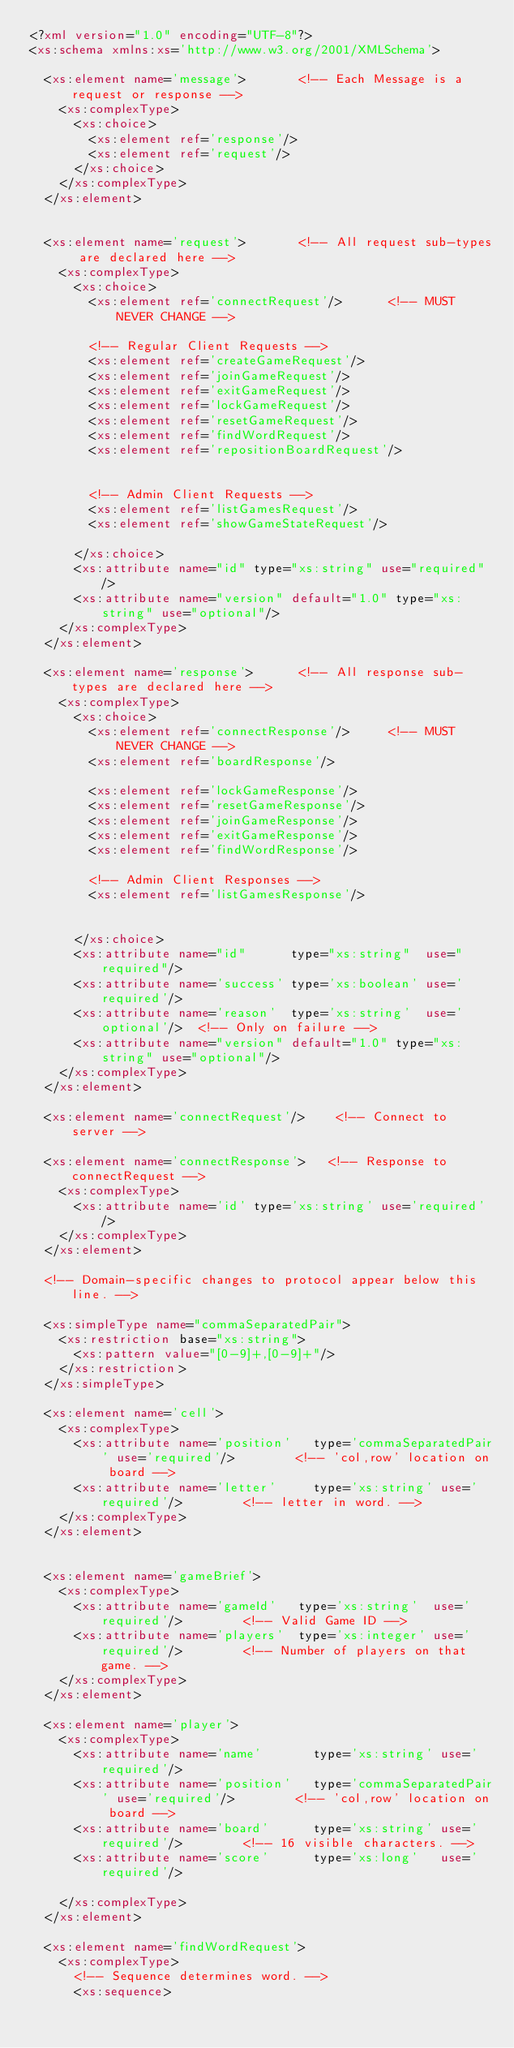<code> <loc_0><loc_0><loc_500><loc_500><_XML_><?xml version="1.0" encoding="UTF-8"?>
<xs:schema xmlns:xs='http://www.w3.org/2001/XMLSchema'>

  <xs:element name='message'>       <!-- Each Message is a request or response -->
    <xs:complexType>
      <xs:choice>
        <xs:element ref='response'/>
        <xs:element ref='request'/>
      </xs:choice>
    </xs:complexType>
  </xs:element>


  <xs:element name='request'>       <!-- All request sub-types are declared here -->
    <xs:complexType>
      <xs:choice>
        <xs:element ref='connectRequest'/>      <!-- MUST NEVER CHANGE -->

        <!-- Regular Client Requests -->
        <xs:element ref='createGameRequest'/>
        <xs:element ref='joinGameRequest'/>
        <xs:element ref='exitGameRequest'/>
        <xs:element ref='lockGameRequest'/>
        <xs:element ref='resetGameRequest'/>
        <xs:element ref='findWordRequest'/>
        <xs:element ref='repositionBoardRequest'/>


        <!-- Admin Client Requests -->
        <xs:element ref='listGamesRequest'/>
        <xs:element ref='showGameStateRequest'/>

      </xs:choice>
      <xs:attribute name="id" type="xs:string" use="required"/>
      <xs:attribute name="version" default="1.0" type="xs:string" use="optional"/>
    </xs:complexType>
  </xs:element>

  <xs:element name='response'>      <!-- All response sub-types are declared here -->
    <xs:complexType>
      <xs:choice>
        <xs:element ref='connectResponse'/>     <!-- MUST NEVER CHANGE -->
        <xs:element ref='boardResponse'/>

        <xs:element ref='lockGameResponse'/>
        <xs:element ref='resetGameResponse'/>
        <xs:element ref='joinGameResponse'/>
        <xs:element ref='exitGameResponse'/>
        <xs:element ref='findWordResponse'/>

        <!-- Admin Client Responses -->
        <xs:element ref='listGamesResponse'/>


      </xs:choice>
      <xs:attribute name="id"      type="xs:string"  use="required"/>
      <xs:attribute name='success' type='xs:boolean' use='required'/>
      <xs:attribute name='reason'  type='xs:string'  use='optional'/>  <!-- Only on failure -->
      <xs:attribute name="version" default="1.0" type="xs:string" use="optional"/>
    </xs:complexType>
  </xs:element>

  <xs:element name='connectRequest'/>    <!-- Connect to server -->

  <xs:element name='connectResponse'>   <!-- Response to connectRequest -->
    <xs:complexType>
      <xs:attribute name='id' type='xs:string' use='required'/>
    </xs:complexType>
  </xs:element>

  <!-- Domain-specific changes to protocol appear below this line. -->

  <xs:simpleType name="commaSeparatedPair">
    <xs:restriction base="xs:string">
      <xs:pattern value="[0-9]+,[0-9]+"/>
    </xs:restriction>
  </xs:simpleType>

  <xs:element name='cell'>
    <xs:complexType>
      <xs:attribute name='position'   type='commaSeparatedPair' use='required'/>        <!-- 'col,row' location on board -->
      <xs:attribute name='letter'     type='xs:string' use='required'/>        <!-- letter in word. -->
    </xs:complexType>
  </xs:element>


  <xs:element name='gameBrief'>
    <xs:complexType>
      <xs:attribute name='gameId'   type='xs:string'  use='required'/>        <!-- Valid Game ID -->
      <xs:attribute name='players'  type='xs:integer' use='required'/>        <!-- Number of players on that game. -->
    </xs:complexType>
  </xs:element>

  <xs:element name='player'>
    <xs:complexType>
      <xs:attribute name='name'       type='xs:string' use='required'/>
      <xs:attribute name='position'   type='commaSeparatedPair' use='required'/>        <!-- 'col,row' location on board -->
      <xs:attribute name='board'      type='xs:string' use='required'/>        <!-- 16 visible characters. -->
      <xs:attribute name='score'      type='xs:long'   use='required'/>

    </xs:complexType>
  </xs:element>

  <xs:element name='findWordRequest'>
    <xs:complexType>
      <!-- Sequence determines word. -->
      <xs:sequence></code> 